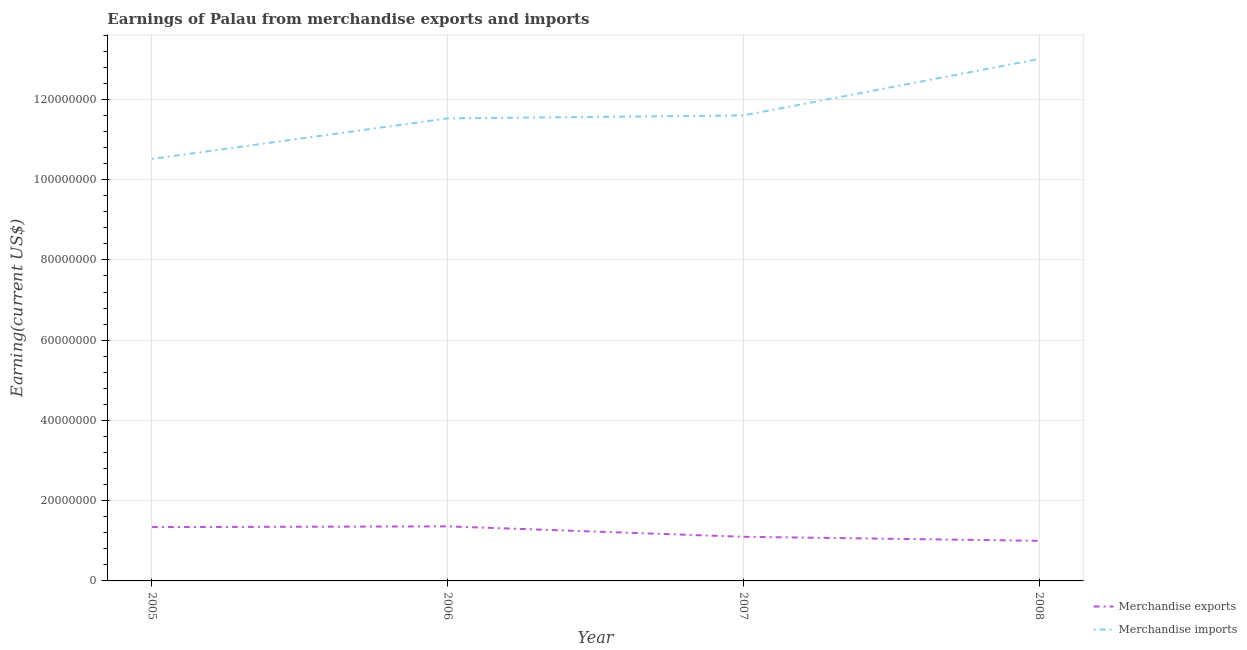What is the earnings from merchandise exports in 2007?
Keep it short and to the point. 1.10e+07. Across all years, what is the maximum earnings from merchandise imports?
Offer a very short reply. 1.30e+08. Across all years, what is the minimum earnings from merchandise exports?
Offer a very short reply. 1.00e+07. In which year was the earnings from merchandise exports minimum?
Your answer should be very brief. 2008. What is the total earnings from merchandise exports in the graph?
Offer a very short reply. 4.80e+07. What is the difference between the earnings from merchandise exports in 2005 and that in 2008?
Provide a short and direct response. 3.41e+06. What is the difference between the earnings from merchandise imports in 2007 and the earnings from merchandise exports in 2006?
Offer a terse response. 1.02e+08. What is the average earnings from merchandise exports per year?
Offer a terse response. 1.20e+07. In the year 2005, what is the difference between the earnings from merchandise exports and earnings from merchandise imports?
Keep it short and to the point. -9.18e+07. In how many years, is the earnings from merchandise exports greater than 124000000 US$?
Make the answer very short. 0. What is the ratio of the earnings from merchandise imports in 2005 to that in 2006?
Give a very brief answer. 0.91. Is the earnings from merchandise imports in 2005 less than that in 2006?
Your answer should be compact. Yes. Is the difference between the earnings from merchandise exports in 2005 and 2008 greater than the difference between the earnings from merchandise imports in 2005 and 2008?
Offer a very short reply. Yes. What is the difference between the highest and the second highest earnings from merchandise imports?
Provide a short and direct response. 1.41e+07. What is the difference between the highest and the lowest earnings from merchandise exports?
Give a very brief answer. 3.59e+06. In how many years, is the earnings from merchandise imports greater than the average earnings from merchandise imports taken over all years?
Make the answer very short. 1. Is the sum of the earnings from merchandise exports in 2005 and 2008 greater than the maximum earnings from merchandise imports across all years?
Keep it short and to the point. No. Is the earnings from merchandise exports strictly less than the earnings from merchandise imports over the years?
Your answer should be very brief. Yes. Are the values on the major ticks of Y-axis written in scientific E-notation?
Your response must be concise. No. Where does the legend appear in the graph?
Provide a succinct answer. Bottom right. How are the legend labels stacked?
Your answer should be compact. Vertical. What is the title of the graph?
Provide a succinct answer. Earnings of Palau from merchandise exports and imports. What is the label or title of the X-axis?
Give a very brief answer. Year. What is the label or title of the Y-axis?
Offer a terse response. Earning(current US$). What is the Earning(current US$) in Merchandise exports in 2005?
Ensure brevity in your answer.  1.34e+07. What is the Earning(current US$) of Merchandise imports in 2005?
Provide a short and direct response. 1.05e+08. What is the Earning(current US$) in Merchandise exports in 2006?
Your response must be concise. 1.36e+07. What is the Earning(current US$) in Merchandise imports in 2006?
Ensure brevity in your answer.  1.15e+08. What is the Earning(current US$) of Merchandise exports in 2007?
Ensure brevity in your answer.  1.10e+07. What is the Earning(current US$) of Merchandise imports in 2007?
Provide a short and direct response. 1.16e+08. What is the Earning(current US$) of Merchandise imports in 2008?
Your answer should be compact. 1.30e+08. Across all years, what is the maximum Earning(current US$) of Merchandise exports?
Provide a short and direct response. 1.36e+07. Across all years, what is the maximum Earning(current US$) in Merchandise imports?
Your answer should be very brief. 1.30e+08. Across all years, what is the minimum Earning(current US$) in Merchandise imports?
Make the answer very short. 1.05e+08. What is the total Earning(current US$) of Merchandise exports in the graph?
Ensure brevity in your answer.  4.80e+07. What is the total Earning(current US$) of Merchandise imports in the graph?
Your answer should be very brief. 4.67e+08. What is the difference between the Earning(current US$) in Merchandise imports in 2005 and that in 2006?
Ensure brevity in your answer.  -1.01e+07. What is the difference between the Earning(current US$) of Merchandise exports in 2005 and that in 2007?
Ensure brevity in your answer.  2.41e+06. What is the difference between the Earning(current US$) of Merchandise imports in 2005 and that in 2007?
Your answer should be compact. -1.08e+07. What is the difference between the Earning(current US$) in Merchandise exports in 2005 and that in 2008?
Give a very brief answer. 3.41e+06. What is the difference between the Earning(current US$) of Merchandise imports in 2005 and that in 2008?
Keep it short and to the point. -2.49e+07. What is the difference between the Earning(current US$) in Merchandise exports in 2006 and that in 2007?
Make the answer very short. 2.59e+06. What is the difference between the Earning(current US$) of Merchandise imports in 2006 and that in 2007?
Offer a very short reply. -7.35e+05. What is the difference between the Earning(current US$) in Merchandise exports in 2006 and that in 2008?
Provide a short and direct response. 3.59e+06. What is the difference between the Earning(current US$) in Merchandise imports in 2006 and that in 2008?
Keep it short and to the point. -1.48e+07. What is the difference between the Earning(current US$) in Merchandise imports in 2007 and that in 2008?
Make the answer very short. -1.41e+07. What is the difference between the Earning(current US$) in Merchandise exports in 2005 and the Earning(current US$) in Merchandise imports in 2006?
Provide a succinct answer. -1.02e+08. What is the difference between the Earning(current US$) of Merchandise exports in 2005 and the Earning(current US$) of Merchandise imports in 2007?
Offer a terse response. -1.03e+08. What is the difference between the Earning(current US$) of Merchandise exports in 2005 and the Earning(current US$) of Merchandise imports in 2008?
Your response must be concise. -1.17e+08. What is the difference between the Earning(current US$) of Merchandise exports in 2006 and the Earning(current US$) of Merchandise imports in 2007?
Provide a succinct answer. -1.02e+08. What is the difference between the Earning(current US$) in Merchandise exports in 2006 and the Earning(current US$) in Merchandise imports in 2008?
Make the answer very short. -1.16e+08. What is the difference between the Earning(current US$) of Merchandise exports in 2007 and the Earning(current US$) of Merchandise imports in 2008?
Make the answer very short. -1.19e+08. What is the average Earning(current US$) of Merchandise exports per year?
Keep it short and to the point. 1.20e+07. What is the average Earning(current US$) in Merchandise imports per year?
Provide a succinct answer. 1.17e+08. In the year 2005, what is the difference between the Earning(current US$) of Merchandise exports and Earning(current US$) of Merchandise imports?
Offer a very short reply. -9.18e+07. In the year 2006, what is the difference between the Earning(current US$) of Merchandise exports and Earning(current US$) of Merchandise imports?
Ensure brevity in your answer.  -1.02e+08. In the year 2007, what is the difference between the Earning(current US$) in Merchandise exports and Earning(current US$) in Merchandise imports?
Provide a short and direct response. -1.05e+08. In the year 2008, what is the difference between the Earning(current US$) of Merchandise exports and Earning(current US$) of Merchandise imports?
Your response must be concise. -1.20e+08. What is the ratio of the Earning(current US$) of Merchandise exports in 2005 to that in 2006?
Ensure brevity in your answer.  0.99. What is the ratio of the Earning(current US$) of Merchandise imports in 2005 to that in 2006?
Your answer should be very brief. 0.91. What is the ratio of the Earning(current US$) of Merchandise exports in 2005 to that in 2007?
Keep it short and to the point. 1.22. What is the ratio of the Earning(current US$) in Merchandise imports in 2005 to that in 2007?
Offer a terse response. 0.91. What is the ratio of the Earning(current US$) of Merchandise exports in 2005 to that in 2008?
Your response must be concise. 1.34. What is the ratio of the Earning(current US$) of Merchandise imports in 2005 to that in 2008?
Ensure brevity in your answer.  0.81. What is the ratio of the Earning(current US$) in Merchandise exports in 2006 to that in 2007?
Ensure brevity in your answer.  1.24. What is the ratio of the Earning(current US$) in Merchandise exports in 2006 to that in 2008?
Keep it short and to the point. 1.36. What is the ratio of the Earning(current US$) of Merchandise imports in 2006 to that in 2008?
Your answer should be very brief. 0.89. What is the ratio of the Earning(current US$) of Merchandise exports in 2007 to that in 2008?
Make the answer very short. 1.1. What is the ratio of the Earning(current US$) in Merchandise imports in 2007 to that in 2008?
Your response must be concise. 0.89. What is the difference between the highest and the second highest Earning(current US$) in Merchandise exports?
Keep it short and to the point. 1.80e+05. What is the difference between the highest and the second highest Earning(current US$) in Merchandise imports?
Give a very brief answer. 1.41e+07. What is the difference between the highest and the lowest Earning(current US$) of Merchandise exports?
Give a very brief answer. 3.59e+06. What is the difference between the highest and the lowest Earning(current US$) of Merchandise imports?
Your answer should be very brief. 2.49e+07. 